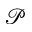Convert formula to latex. <formula><loc_0><loc_0><loc_500><loc_500>\mathcal { P }</formula> 